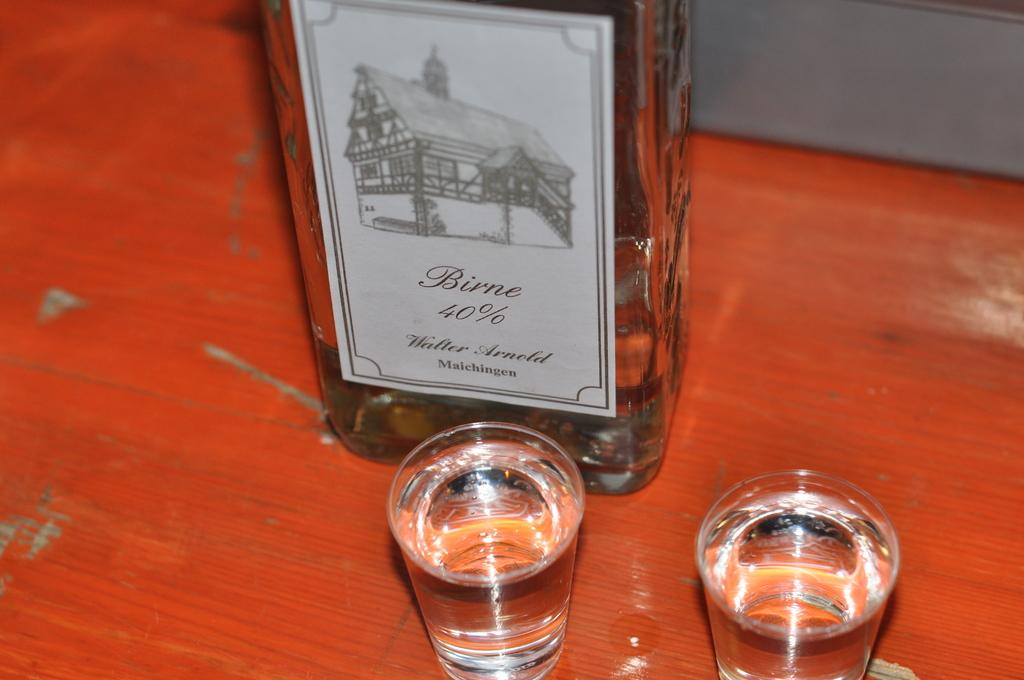<image>
Provide a brief description of the given image. A bottle of liquor has the amount 40% on the label. 